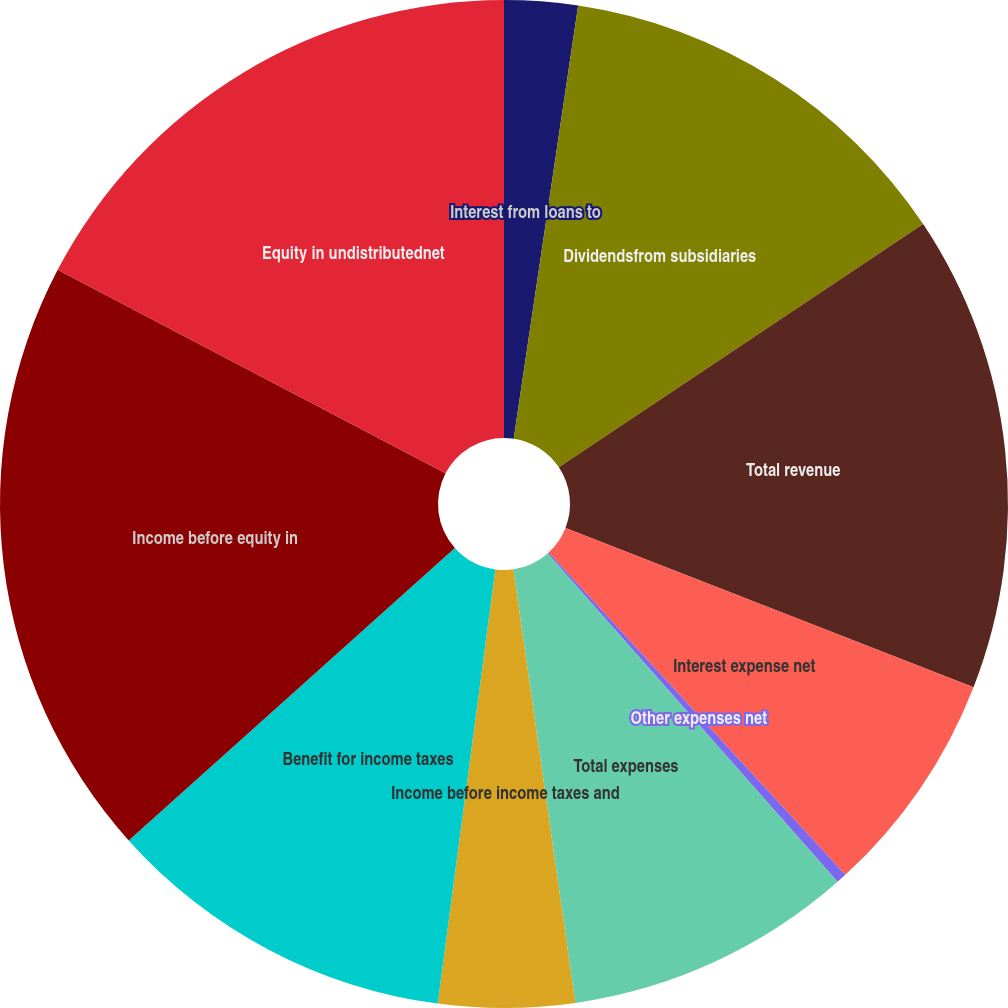Convert chart. <chart><loc_0><loc_0><loc_500><loc_500><pie_chart><fcel>Interest from loans to<fcel>Dividendsfrom subsidiaries<fcel>Total revenue<fcel>Interest expense net<fcel>Other expenses net<fcel>Total expenses<fcel>Income before income taxes and<fcel>Benefit for income taxes<fcel>Income before equity in<fcel>Equity in undistributednet<nl><fcel>2.35%<fcel>13.28%<fcel>15.29%<fcel>7.24%<fcel>0.33%<fcel>9.25%<fcel>4.36%<fcel>11.27%<fcel>19.32%<fcel>17.31%<nl></chart> 